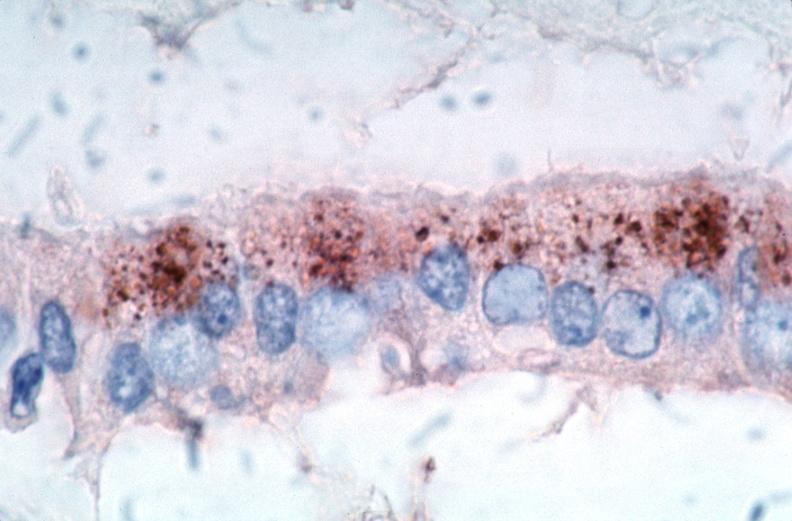s intraductal papillomatosis with apocrine metaplasia present?
Answer the question using a single word or phrase. No 